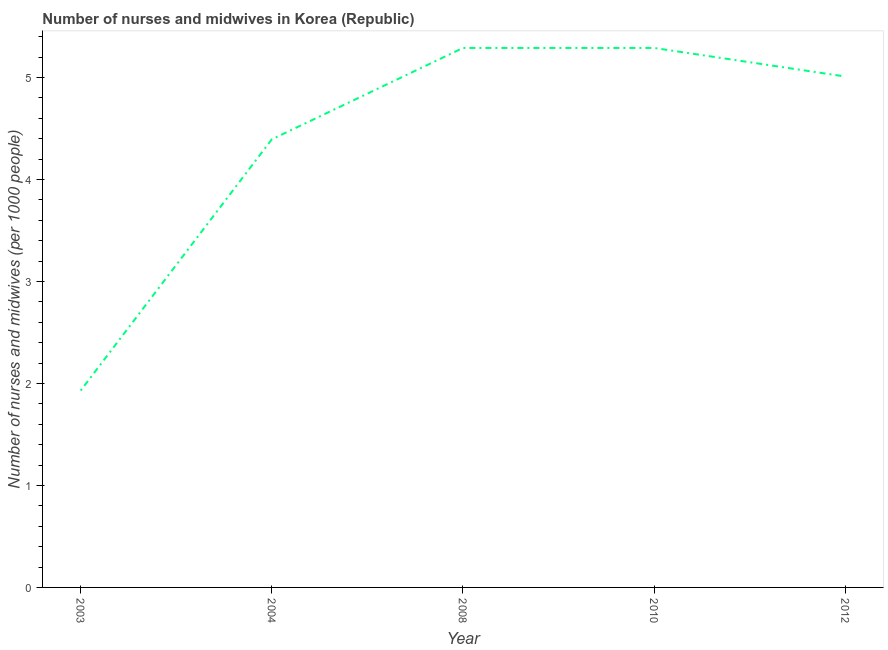What is the number of nurses and midwives in 2012?
Provide a short and direct response. 5.01. Across all years, what is the maximum number of nurses and midwives?
Your answer should be very brief. 5.29. Across all years, what is the minimum number of nurses and midwives?
Your answer should be compact. 1.93. In which year was the number of nurses and midwives maximum?
Ensure brevity in your answer.  2008. In which year was the number of nurses and midwives minimum?
Your answer should be very brief. 2003. What is the sum of the number of nurses and midwives?
Ensure brevity in your answer.  21.91. What is the difference between the number of nurses and midwives in 2008 and 2010?
Your answer should be compact. 0. What is the average number of nurses and midwives per year?
Offer a terse response. 4.38. What is the median number of nurses and midwives?
Offer a terse response. 5.01. What is the ratio of the number of nurses and midwives in 2003 to that in 2010?
Give a very brief answer. 0.36. Is the number of nurses and midwives in 2003 less than that in 2012?
Offer a very short reply. Yes. Is the difference between the number of nurses and midwives in 2008 and 2010 greater than the difference between any two years?
Offer a terse response. No. What is the difference between the highest and the second highest number of nurses and midwives?
Your answer should be compact. 0. What is the difference between the highest and the lowest number of nurses and midwives?
Keep it short and to the point. 3.36. Does the number of nurses and midwives monotonically increase over the years?
Ensure brevity in your answer.  No. How many lines are there?
Your answer should be compact. 1. How many years are there in the graph?
Provide a succinct answer. 5. Does the graph contain any zero values?
Your answer should be compact. No. What is the title of the graph?
Give a very brief answer. Number of nurses and midwives in Korea (Republic). What is the label or title of the Y-axis?
Your answer should be very brief. Number of nurses and midwives (per 1000 people). What is the Number of nurses and midwives (per 1000 people) in 2003?
Make the answer very short. 1.93. What is the Number of nurses and midwives (per 1000 people) in 2004?
Make the answer very short. 4.39. What is the Number of nurses and midwives (per 1000 people) in 2008?
Ensure brevity in your answer.  5.29. What is the Number of nurses and midwives (per 1000 people) in 2010?
Your answer should be very brief. 5.29. What is the Number of nurses and midwives (per 1000 people) in 2012?
Keep it short and to the point. 5.01. What is the difference between the Number of nurses and midwives (per 1000 people) in 2003 and 2004?
Your answer should be very brief. -2.46. What is the difference between the Number of nurses and midwives (per 1000 people) in 2003 and 2008?
Your answer should be very brief. -3.36. What is the difference between the Number of nurses and midwives (per 1000 people) in 2003 and 2010?
Offer a terse response. -3.36. What is the difference between the Number of nurses and midwives (per 1000 people) in 2003 and 2012?
Give a very brief answer. -3.08. What is the difference between the Number of nurses and midwives (per 1000 people) in 2004 and 2008?
Provide a short and direct response. -0.9. What is the difference between the Number of nurses and midwives (per 1000 people) in 2004 and 2010?
Offer a terse response. -0.9. What is the difference between the Number of nurses and midwives (per 1000 people) in 2004 and 2012?
Ensure brevity in your answer.  -0.62. What is the difference between the Number of nurses and midwives (per 1000 people) in 2008 and 2010?
Ensure brevity in your answer.  0. What is the difference between the Number of nurses and midwives (per 1000 people) in 2008 and 2012?
Ensure brevity in your answer.  0.28. What is the difference between the Number of nurses and midwives (per 1000 people) in 2010 and 2012?
Ensure brevity in your answer.  0.28. What is the ratio of the Number of nurses and midwives (per 1000 people) in 2003 to that in 2004?
Make the answer very short. 0.44. What is the ratio of the Number of nurses and midwives (per 1000 people) in 2003 to that in 2008?
Your answer should be compact. 0.36. What is the ratio of the Number of nurses and midwives (per 1000 people) in 2003 to that in 2010?
Provide a short and direct response. 0.36. What is the ratio of the Number of nurses and midwives (per 1000 people) in 2003 to that in 2012?
Your response must be concise. 0.39. What is the ratio of the Number of nurses and midwives (per 1000 people) in 2004 to that in 2008?
Your response must be concise. 0.83. What is the ratio of the Number of nurses and midwives (per 1000 people) in 2004 to that in 2010?
Make the answer very short. 0.83. What is the ratio of the Number of nurses and midwives (per 1000 people) in 2004 to that in 2012?
Give a very brief answer. 0.88. What is the ratio of the Number of nurses and midwives (per 1000 people) in 2008 to that in 2010?
Offer a terse response. 1. What is the ratio of the Number of nurses and midwives (per 1000 people) in 2008 to that in 2012?
Keep it short and to the point. 1.06. What is the ratio of the Number of nurses and midwives (per 1000 people) in 2010 to that in 2012?
Your answer should be very brief. 1.06. 